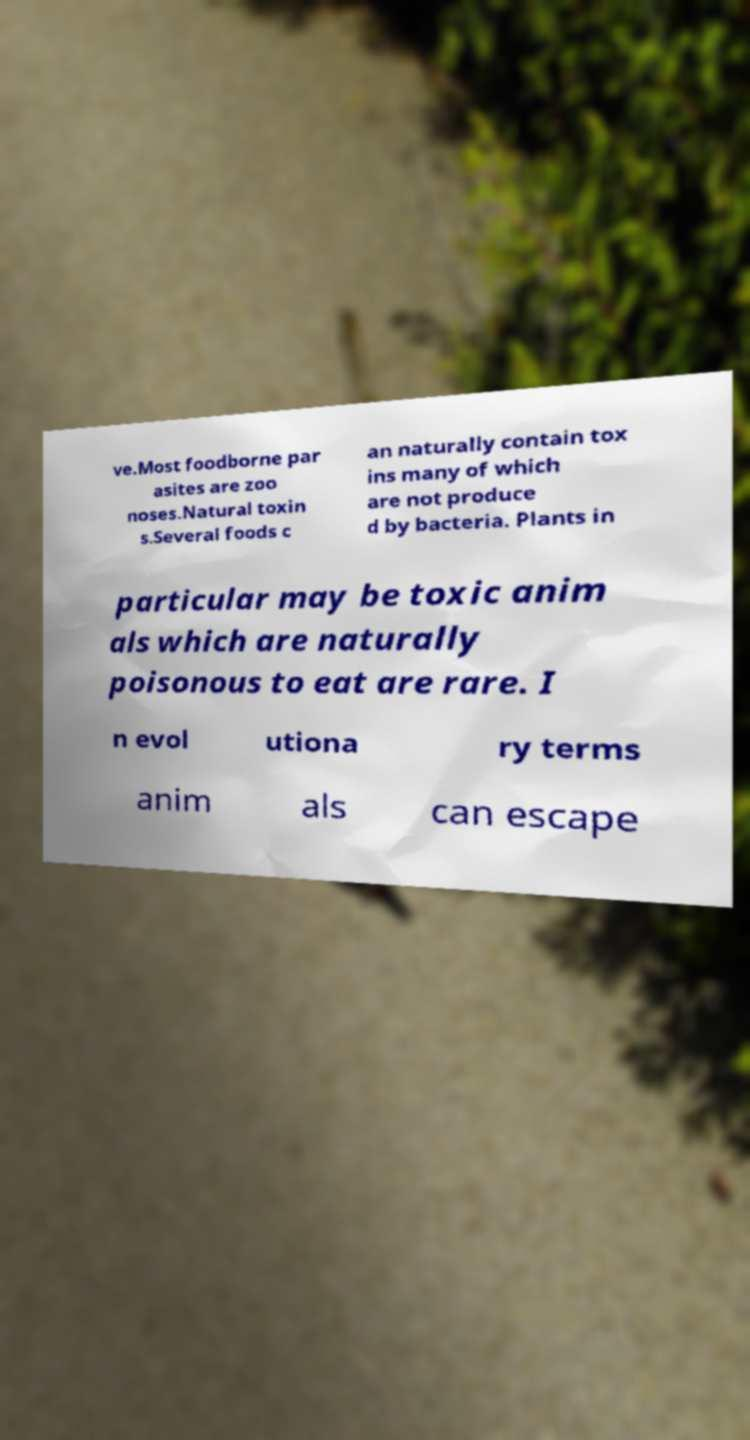Could you assist in decoding the text presented in this image and type it out clearly? ve.Most foodborne par asites are zoo noses.Natural toxin s.Several foods c an naturally contain tox ins many of which are not produce d by bacteria. Plants in particular may be toxic anim als which are naturally poisonous to eat are rare. I n evol utiona ry terms anim als can escape 